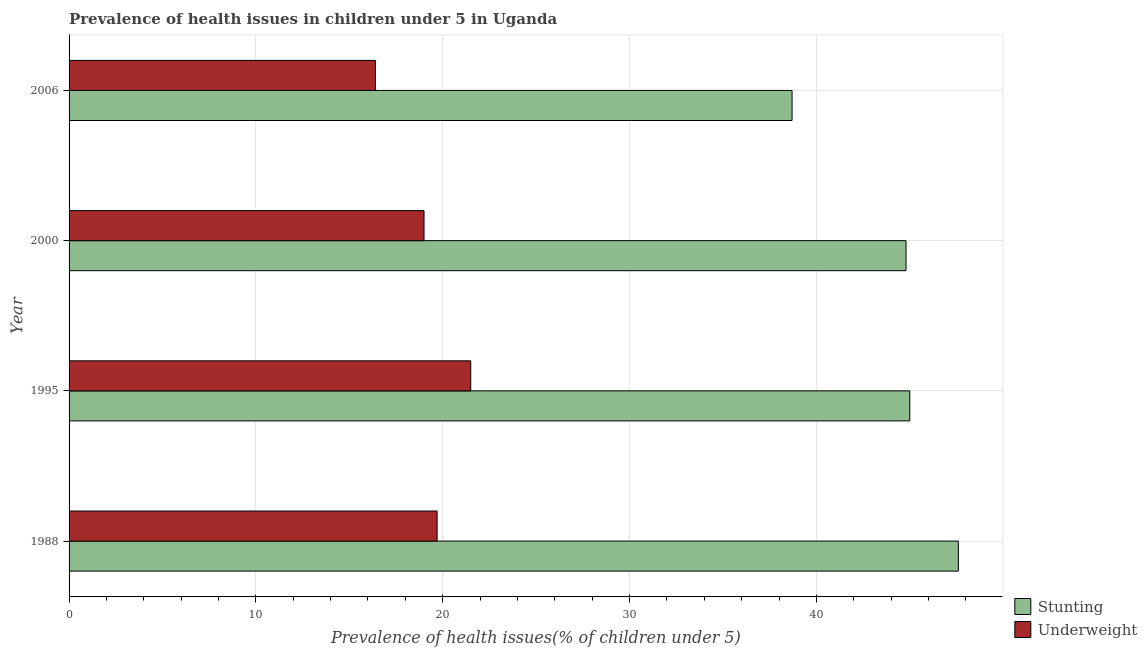How many groups of bars are there?
Make the answer very short. 4. How many bars are there on the 2nd tick from the top?
Ensure brevity in your answer.  2. In how many cases, is the number of bars for a given year not equal to the number of legend labels?
Your answer should be compact. 0. What is the percentage of stunted children in 1988?
Give a very brief answer. 47.6. Across all years, what is the maximum percentage of underweight children?
Your answer should be very brief. 21.5. Across all years, what is the minimum percentage of stunted children?
Keep it short and to the point. 38.7. In which year was the percentage of stunted children maximum?
Offer a terse response. 1988. What is the total percentage of stunted children in the graph?
Offer a terse response. 176.1. What is the average percentage of stunted children per year?
Give a very brief answer. 44.02. In the year 2000, what is the difference between the percentage of stunted children and percentage of underweight children?
Your answer should be very brief. 25.8. In how many years, is the percentage of stunted children greater than 36 %?
Your response must be concise. 4. What is the ratio of the percentage of underweight children in 1988 to that in 2006?
Give a very brief answer. 1.2. Is the percentage of underweight children in 1988 less than that in 2006?
Offer a terse response. No. What is the difference between the highest and the lowest percentage of stunted children?
Your answer should be compact. 8.9. Is the sum of the percentage of stunted children in 1988 and 2006 greater than the maximum percentage of underweight children across all years?
Make the answer very short. Yes. What does the 2nd bar from the top in 1995 represents?
Make the answer very short. Stunting. What does the 1st bar from the bottom in 2000 represents?
Your response must be concise. Stunting. Are all the bars in the graph horizontal?
Make the answer very short. Yes. How many years are there in the graph?
Your answer should be compact. 4. What is the difference between two consecutive major ticks on the X-axis?
Offer a very short reply. 10. Are the values on the major ticks of X-axis written in scientific E-notation?
Provide a short and direct response. No. Does the graph contain any zero values?
Your response must be concise. No. What is the title of the graph?
Provide a short and direct response. Prevalence of health issues in children under 5 in Uganda. Does "RDB concessional" appear as one of the legend labels in the graph?
Offer a very short reply. No. What is the label or title of the X-axis?
Your answer should be compact. Prevalence of health issues(% of children under 5). What is the Prevalence of health issues(% of children under 5) of Stunting in 1988?
Ensure brevity in your answer.  47.6. What is the Prevalence of health issues(% of children under 5) of Underweight in 1988?
Offer a very short reply. 19.7. What is the Prevalence of health issues(% of children under 5) of Stunting in 2000?
Offer a terse response. 44.8. What is the Prevalence of health issues(% of children under 5) of Stunting in 2006?
Provide a short and direct response. 38.7. What is the Prevalence of health issues(% of children under 5) in Underweight in 2006?
Offer a terse response. 16.4. Across all years, what is the maximum Prevalence of health issues(% of children under 5) in Stunting?
Give a very brief answer. 47.6. Across all years, what is the minimum Prevalence of health issues(% of children under 5) of Stunting?
Offer a very short reply. 38.7. Across all years, what is the minimum Prevalence of health issues(% of children under 5) of Underweight?
Offer a very short reply. 16.4. What is the total Prevalence of health issues(% of children under 5) in Stunting in the graph?
Your answer should be compact. 176.1. What is the total Prevalence of health issues(% of children under 5) in Underweight in the graph?
Offer a terse response. 76.6. What is the difference between the Prevalence of health issues(% of children under 5) of Stunting in 1988 and that in 1995?
Give a very brief answer. 2.6. What is the difference between the Prevalence of health issues(% of children under 5) in Underweight in 1988 and that in 1995?
Offer a very short reply. -1.8. What is the difference between the Prevalence of health issues(% of children under 5) of Stunting in 1988 and that in 2000?
Make the answer very short. 2.8. What is the difference between the Prevalence of health issues(% of children under 5) of Underweight in 1988 and that in 2000?
Offer a terse response. 0.7. What is the difference between the Prevalence of health issues(% of children under 5) of Stunting in 1988 and that in 2006?
Give a very brief answer. 8.9. What is the difference between the Prevalence of health issues(% of children under 5) in Underweight in 1988 and that in 2006?
Offer a very short reply. 3.3. What is the difference between the Prevalence of health issues(% of children under 5) in Stunting in 1995 and that in 2000?
Offer a very short reply. 0.2. What is the difference between the Prevalence of health issues(% of children under 5) of Stunting in 1995 and that in 2006?
Make the answer very short. 6.3. What is the difference between the Prevalence of health issues(% of children under 5) of Stunting in 2000 and that in 2006?
Keep it short and to the point. 6.1. What is the difference between the Prevalence of health issues(% of children under 5) in Underweight in 2000 and that in 2006?
Your answer should be very brief. 2.6. What is the difference between the Prevalence of health issues(% of children under 5) of Stunting in 1988 and the Prevalence of health issues(% of children under 5) of Underweight in 1995?
Provide a succinct answer. 26.1. What is the difference between the Prevalence of health issues(% of children under 5) in Stunting in 1988 and the Prevalence of health issues(% of children under 5) in Underweight in 2000?
Offer a very short reply. 28.6. What is the difference between the Prevalence of health issues(% of children under 5) of Stunting in 1988 and the Prevalence of health issues(% of children under 5) of Underweight in 2006?
Offer a very short reply. 31.2. What is the difference between the Prevalence of health issues(% of children under 5) of Stunting in 1995 and the Prevalence of health issues(% of children under 5) of Underweight in 2006?
Make the answer very short. 28.6. What is the difference between the Prevalence of health issues(% of children under 5) in Stunting in 2000 and the Prevalence of health issues(% of children under 5) in Underweight in 2006?
Ensure brevity in your answer.  28.4. What is the average Prevalence of health issues(% of children under 5) in Stunting per year?
Your answer should be compact. 44.02. What is the average Prevalence of health issues(% of children under 5) in Underweight per year?
Keep it short and to the point. 19.15. In the year 1988, what is the difference between the Prevalence of health issues(% of children under 5) of Stunting and Prevalence of health issues(% of children under 5) of Underweight?
Provide a short and direct response. 27.9. In the year 1995, what is the difference between the Prevalence of health issues(% of children under 5) of Stunting and Prevalence of health issues(% of children under 5) of Underweight?
Your answer should be compact. 23.5. In the year 2000, what is the difference between the Prevalence of health issues(% of children under 5) of Stunting and Prevalence of health issues(% of children under 5) of Underweight?
Keep it short and to the point. 25.8. In the year 2006, what is the difference between the Prevalence of health issues(% of children under 5) in Stunting and Prevalence of health issues(% of children under 5) in Underweight?
Make the answer very short. 22.3. What is the ratio of the Prevalence of health issues(% of children under 5) of Stunting in 1988 to that in 1995?
Your answer should be compact. 1.06. What is the ratio of the Prevalence of health issues(% of children under 5) of Underweight in 1988 to that in 1995?
Provide a succinct answer. 0.92. What is the ratio of the Prevalence of health issues(% of children under 5) of Stunting in 1988 to that in 2000?
Your answer should be very brief. 1.06. What is the ratio of the Prevalence of health issues(% of children under 5) in Underweight in 1988 to that in 2000?
Provide a short and direct response. 1.04. What is the ratio of the Prevalence of health issues(% of children under 5) of Stunting in 1988 to that in 2006?
Your answer should be compact. 1.23. What is the ratio of the Prevalence of health issues(% of children under 5) in Underweight in 1988 to that in 2006?
Give a very brief answer. 1.2. What is the ratio of the Prevalence of health issues(% of children under 5) of Stunting in 1995 to that in 2000?
Offer a terse response. 1. What is the ratio of the Prevalence of health issues(% of children under 5) of Underweight in 1995 to that in 2000?
Your answer should be compact. 1.13. What is the ratio of the Prevalence of health issues(% of children under 5) of Stunting in 1995 to that in 2006?
Offer a very short reply. 1.16. What is the ratio of the Prevalence of health issues(% of children under 5) of Underweight in 1995 to that in 2006?
Provide a succinct answer. 1.31. What is the ratio of the Prevalence of health issues(% of children under 5) of Stunting in 2000 to that in 2006?
Ensure brevity in your answer.  1.16. What is the ratio of the Prevalence of health issues(% of children under 5) of Underweight in 2000 to that in 2006?
Keep it short and to the point. 1.16. What is the difference between the highest and the second highest Prevalence of health issues(% of children under 5) in Stunting?
Your answer should be compact. 2.6. What is the difference between the highest and the lowest Prevalence of health issues(% of children under 5) of Underweight?
Keep it short and to the point. 5.1. 